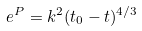Convert formula to latex. <formula><loc_0><loc_0><loc_500><loc_500>e ^ { P } = k ^ { 2 } ( t _ { 0 } - t ) ^ { 4 / 3 }</formula> 